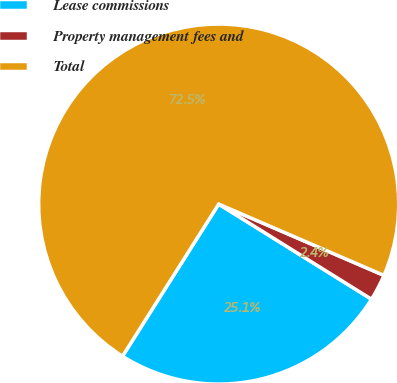<chart> <loc_0><loc_0><loc_500><loc_500><pie_chart><fcel>Lease commissions<fcel>Property management fees and<fcel>Total<nl><fcel>25.11%<fcel>2.38%<fcel>72.51%<nl></chart> 